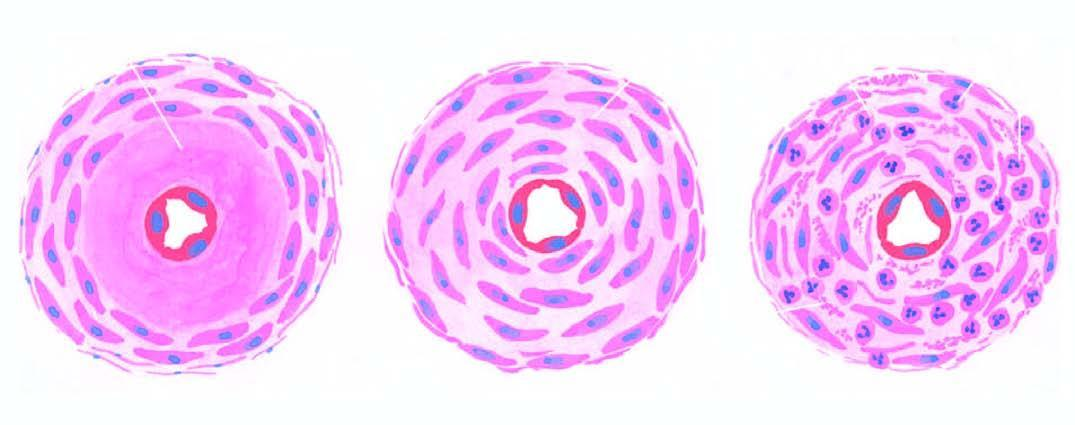where is diagrammatic representation of three forms of arteriolosclerosis seen?
Answer the question using a single word or phrase. In hypertension 